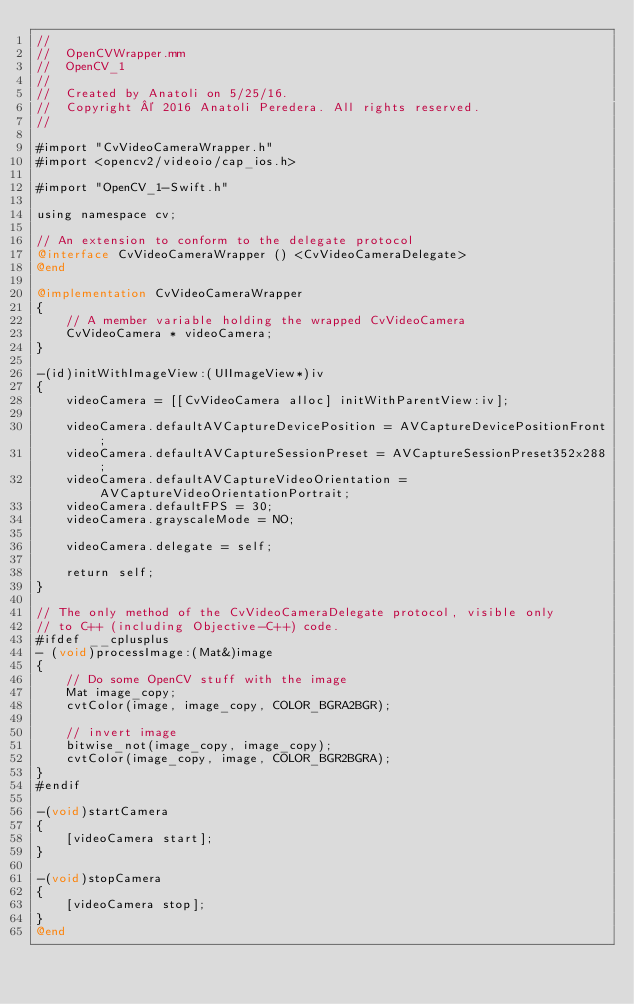<code> <loc_0><loc_0><loc_500><loc_500><_ObjectiveC_>//
//  OpenCVWrapper.mm
//  OpenCV_1
//
//  Created by Anatoli on 5/25/16.
//  Copyright © 2016 Anatoli Peredera. All rights reserved.
//

#import "CvVideoCameraWrapper.h"
#import <opencv2/videoio/cap_ios.h>

#import "OpenCV_1-Swift.h"

using namespace cv;

// An extension to conform to the delegate protocol
@interface CvVideoCameraWrapper () <CvVideoCameraDelegate>
@end

@implementation CvVideoCameraWrapper
{
    // A member variable holding the wrapped CvVideoCamera
    CvVideoCamera * videoCamera;
}

-(id)initWithImageView:(UIImageView*)iv
{
    videoCamera = [[CvVideoCamera alloc] initWithParentView:iv];
    
    videoCamera.defaultAVCaptureDevicePosition = AVCaptureDevicePositionFront;
    videoCamera.defaultAVCaptureSessionPreset = AVCaptureSessionPreset352x288;
    videoCamera.defaultAVCaptureVideoOrientation = AVCaptureVideoOrientationPortrait;
    videoCamera.defaultFPS = 30;
    videoCamera.grayscaleMode = NO;
    
    videoCamera.delegate = self;
    
    return self;
}

// The only method of the CvVideoCameraDelegate protocol, visible only
// to C++ (including Objective-C++) code.
#ifdef __cplusplus 
- (void)processImage:(Mat&)image
{
    // Do some OpenCV stuff with the image
    Mat image_copy;
    cvtColor(image, image_copy, COLOR_BGRA2BGR);
    
    // invert image
    bitwise_not(image_copy, image_copy);
    cvtColor(image_copy, image, COLOR_BGR2BGRA);
}
#endif

-(void)startCamera
{
    [videoCamera start];
}

-(void)stopCamera
{
    [videoCamera stop];
}
@end
</code> 